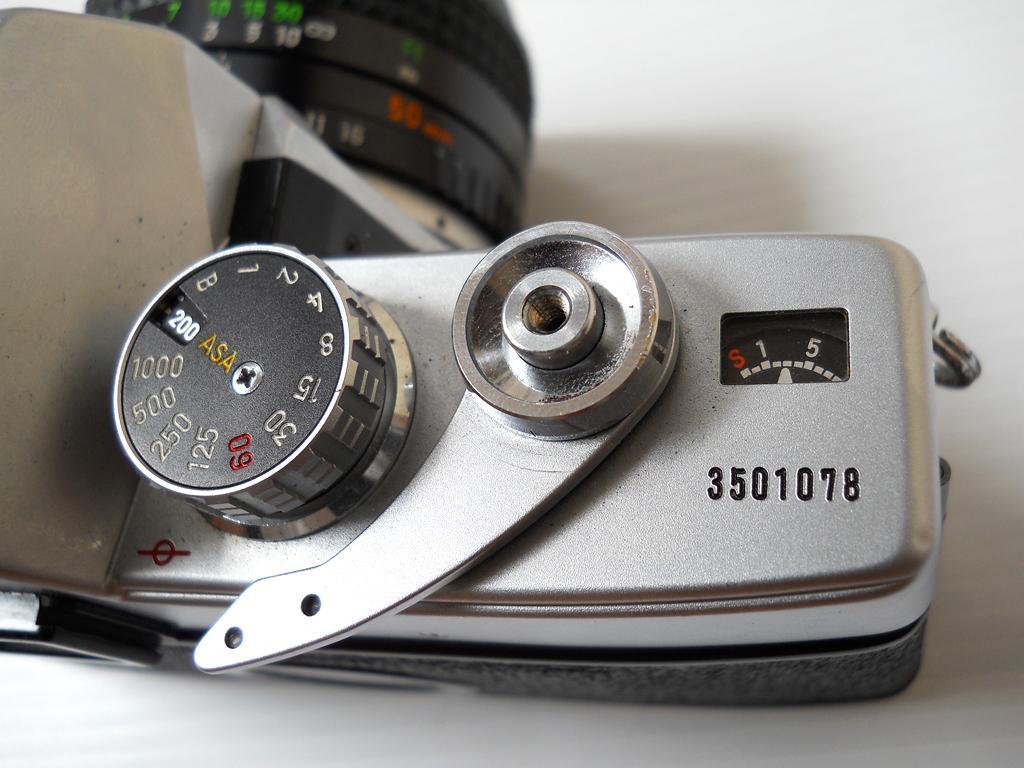Can you describe this image briefly? In this image we can see a camera with numbers and it is on a white surface. 